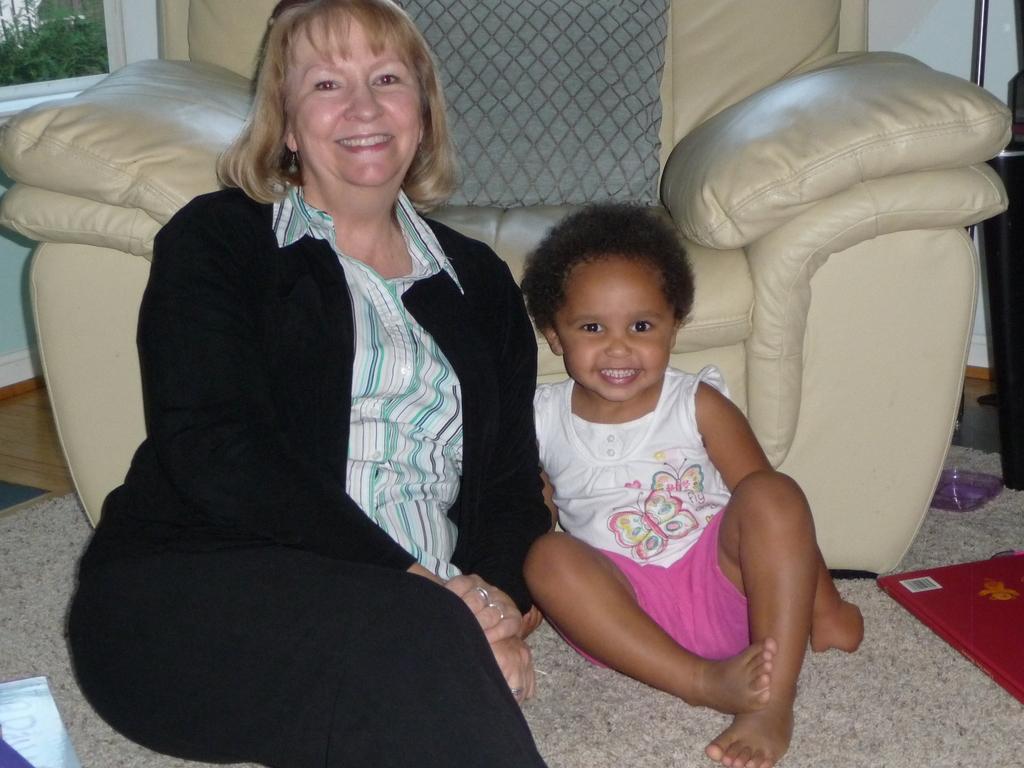Please provide a concise description of this image. In the image there is a woman in suit sitting on floor beside a baby in front of a recliner, on the left side it seems to be window on the wall with plants behind it. 